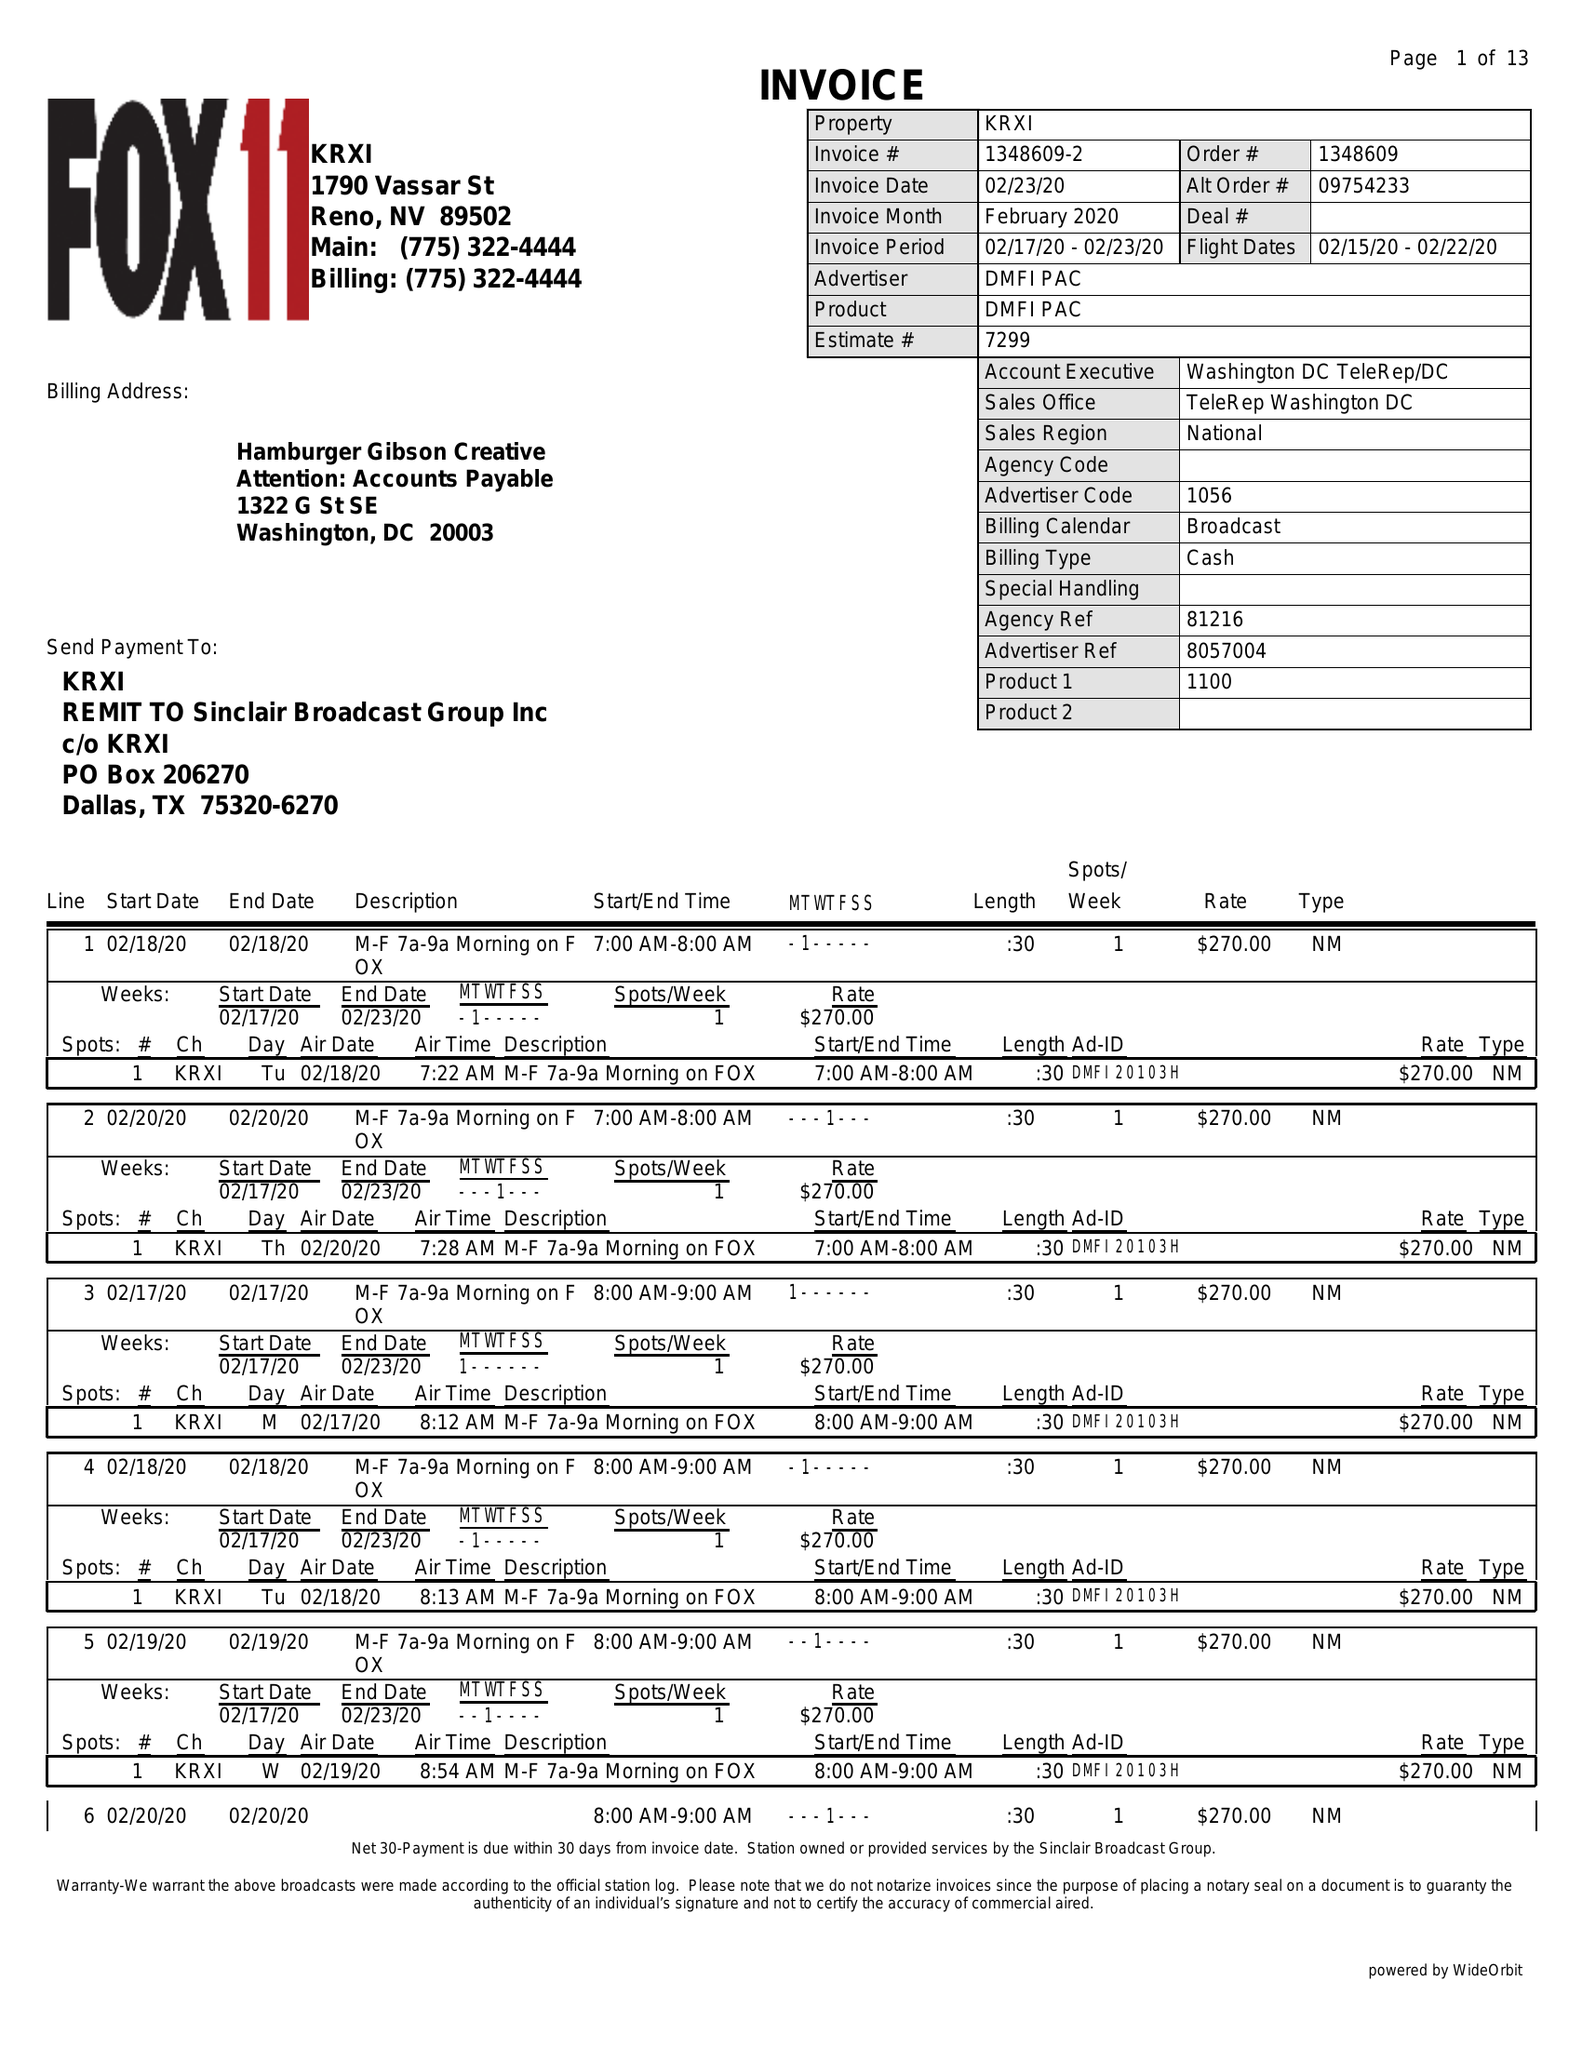What is the value for the flight_to?
Answer the question using a single word or phrase. 02/22/20 